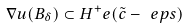Convert formula to latex. <formula><loc_0><loc_0><loc_500><loc_500>\nabla u ( B _ { \delta } ) \subset H ^ { + } _ { \ } e ( \tilde { c } - \ e p s )</formula> 